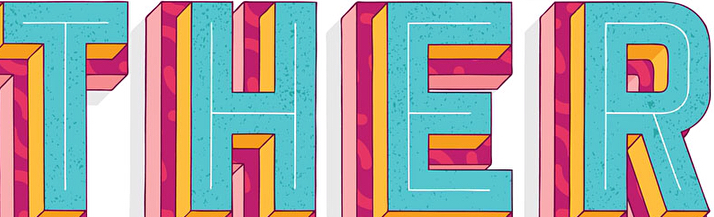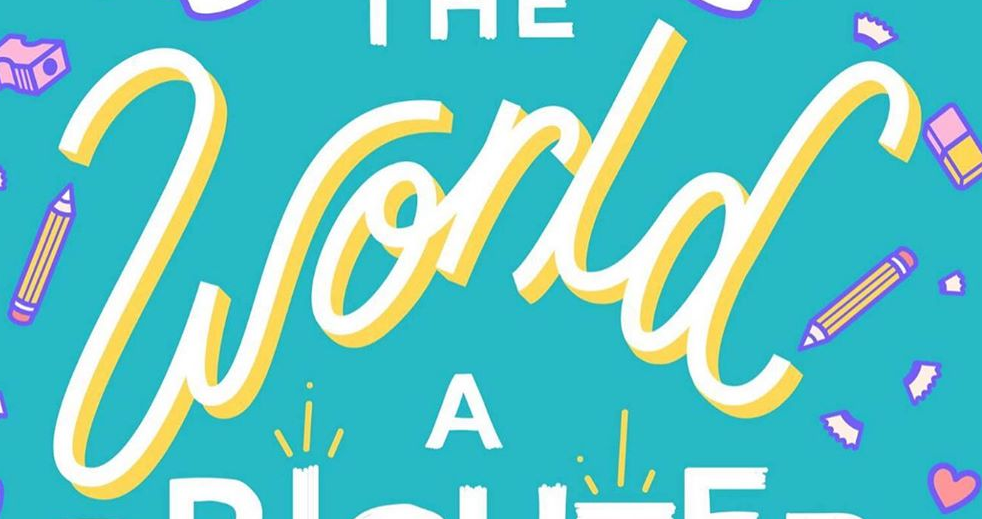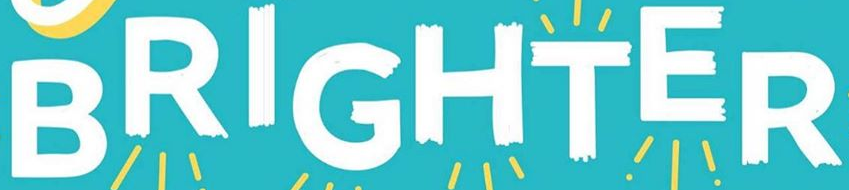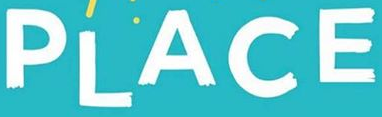What text is displayed in these images sequentially, separated by a semicolon? THER; world; BRIGHTER; PLACE 